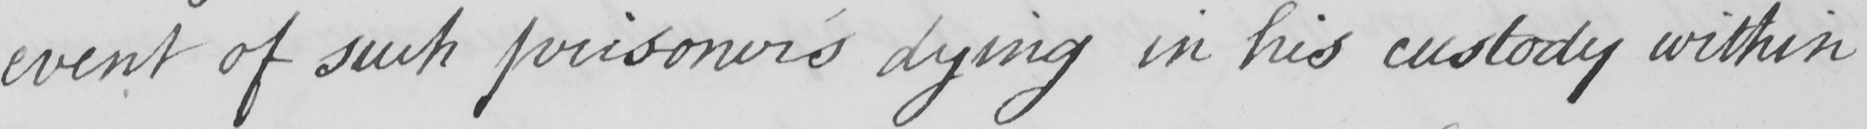What does this handwritten line say? event of such prisoner ' s dying in his custody within 